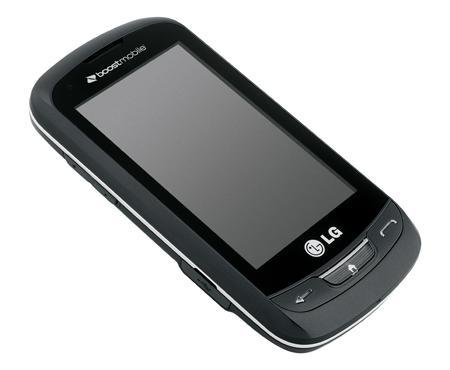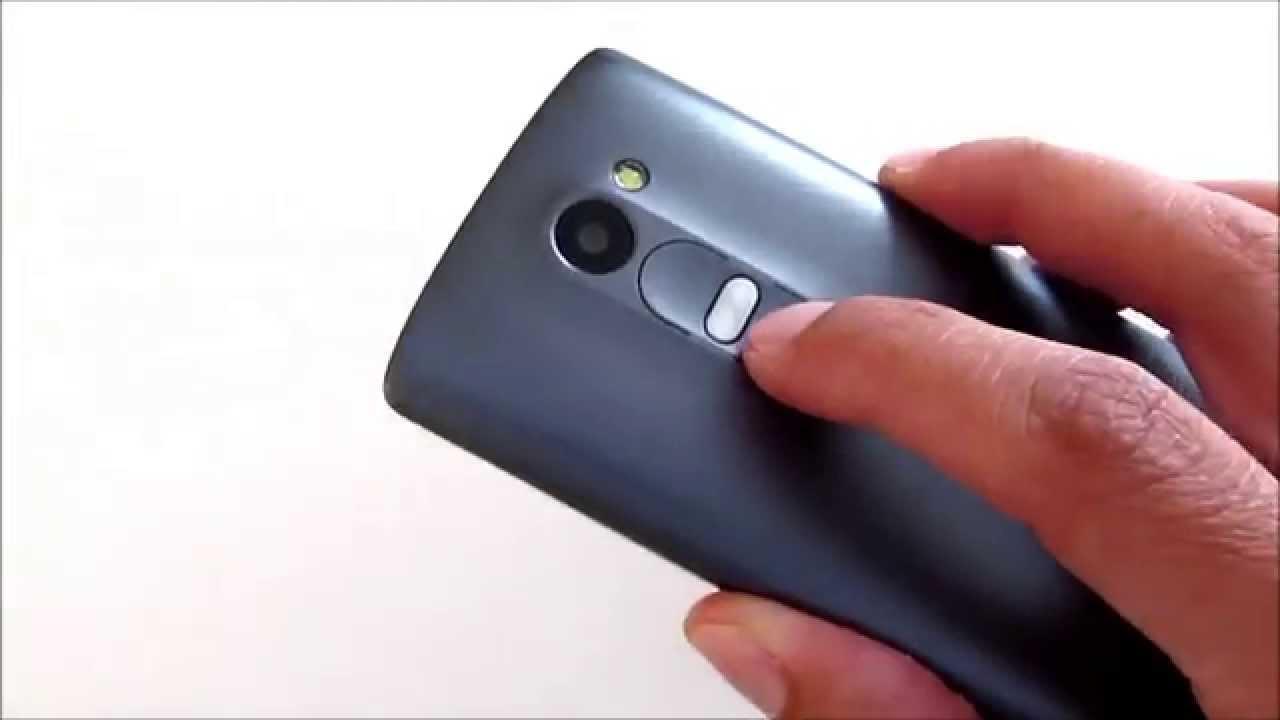The first image is the image on the left, the second image is the image on the right. Considering the images on both sides, is "Only one hand is visible." valid? Answer yes or no. Yes. The first image is the image on the left, the second image is the image on the right. Analyze the images presented: Is the assertion "One image shows a rectangular gray phone with a gray screen, and the other image shows a hand holding a phone." valid? Answer yes or no. Yes. 